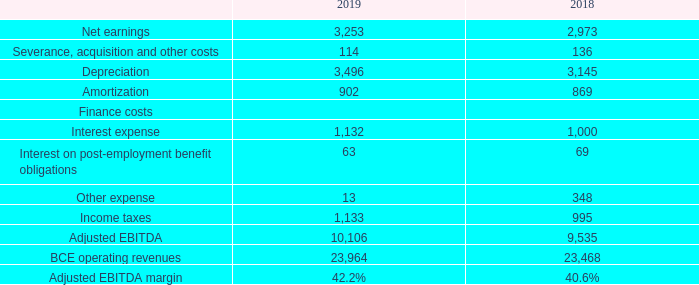ADJUSTED EBITDA AND ADJUSTED EBITDA MARGIN
The terms adjusted EBITDA and adjusted EBITDA margin do not have any standardized meaning under IFRS. Therefore, they are unlikely to be comparable to similar measures presented by other issuers.
We define adjusted EBITDA as operating revenues less operating costs as shown in BCE’s consolidated income statements. Adjusted EBITDA for BCE’s segments is the same as segment profit as reported in Note 3, Segmented information, in BCE’s 2019 consolidated financial statements. We define adjusted EBITDA margin as adjusted EBITDA divided by operating revenues.
We use adjusted EBITDA and adjusted EBITDA margin to evaluate the performance of our businesses as they reflect their ongoing profitability. We believe that certain investors and analysts use adjusted EBITDA to measure a company’s ability to service debt and to meet other payment obligations or as a common measurement to value companies in the telecommunications industry. We believe that certain investors and analysts also use adjusted EBITDA and adjusted EBITDA margin to evaluate the performance of our businesses. Adjusted EBITDA is also one component in the determination of short-term incentive compensation for all management employees.
Adjusted EBITDA and adjusted EBITDA margin have no directly comparable IFRS financial measure. Alternatively, the following table provides a reconciliation of net earnings to adjusted EBITDA.
How is adjusted EBITDA defined? Operating revenues less operating costs as shown in bce’s consolidated income statements. How is adjusted EBITDA margin defined? Adjusted ebitda divided by operating revenues. What is the Net earnings for 2019? 3,253. What is the percentage of interest expense of finance costs in 2018?
Answer scale should be: percent. 1,000/(1,000+69)
Answer: 93.55. What is the change in the adjusted EBITDA margin in 2019?
Answer scale should be: percent. 42.2%-40.6%
Answer: 1.6. What is the total net earnings in 2018 and 2019? 3,253+2,973
Answer: 6226. 